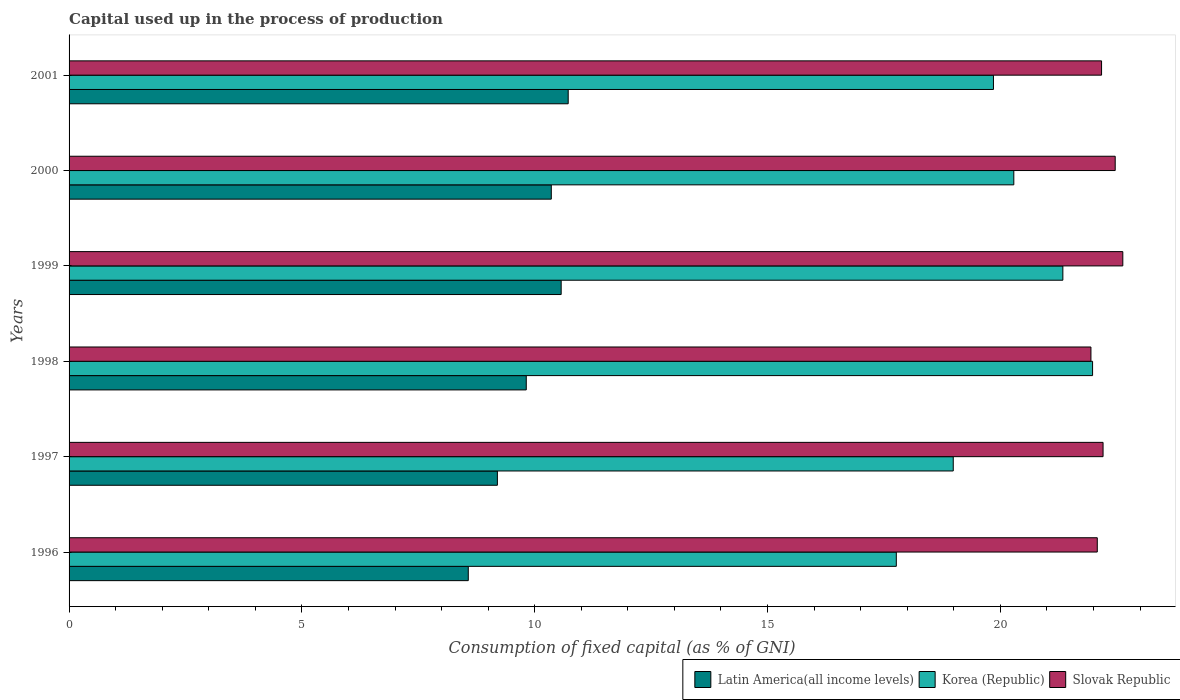How many different coloured bars are there?
Offer a very short reply. 3. What is the capital used up in the process of production in Slovak Republic in 2000?
Give a very brief answer. 22.47. Across all years, what is the maximum capital used up in the process of production in Korea (Republic)?
Ensure brevity in your answer.  21.98. Across all years, what is the minimum capital used up in the process of production in Korea (Republic)?
Provide a succinct answer. 17.77. In which year was the capital used up in the process of production in Latin America(all income levels) minimum?
Make the answer very short. 1996. What is the total capital used up in the process of production in Korea (Republic) in the graph?
Your response must be concise. 120.22. What is the difference between the capital used up in the process of production in Latin America(all income levels) in 1996 and that in 2000?
Your answer should be compact. -1.78. What is the difference between the capital used up in the process of production in Latin America(all income levels) in 1996 and the capital used up in the process of production in Slovak Republic in 1997?
Your answer should be very brief. -13.63. What is the average capital used up in the process of production in Slovak Republic per year?
Make the answer very short. 22.25. In the year 2000, what is the difference between the capital used up in the process of production in Korea (Republic) and capital used up in the process of production in Latin America(all income levels)?
Provide a short and direct response. 9.93. What is the ratio of the capital used up in the process of production in Slovak Republic in 1998 to that in 2000?
Make the answer very short. 0.98. Is the capital used up in the process of production in Latin America(all income levels) in 1997 less than that in 2000?
Your answer should be compact. Yes. What is the difference between the highest and the second highest capital used up in the process of production in Korea (Republic)?
Keep it short and to the point. 0.64. What is the difference between the highest and the lowest capital used up in the process of production in Slovak Republic?
Provide a short and direct response. 0.68. In how many years, is the capital used up in the process of production in Slovak Republic greater than the average capital used up in the process of production in Slovak Republic taken over all years?
Ensure brevity in your answer.  2. What does the 1st bar from the top in 1997 represents?
Provide a short and direct response. Slovak Republic. How many bars are there?
Make the answer very short. 18. Are all the bars in the graph horizontal?
Offer a terse response. Yes. How many years are there in the graph?
Offer a terse response. 6. Are the values on the major ticks of X-axis written in scientific E-notation?
Offer a terse response. No. Does the graph contain grids?
Keep it short and to the point. No. Where does the legend appear in the graph?
Make the answer very short. Bottom right. How many legend labels are there?
Keep it short and to the point. 3. What is the title of the graph?
Offer a terse response. Capital used up in the process of production. Does "Australia" appear as one of the legend labels in the graph?
Your answer should be compact. No. What is the label or title of the X-axis?
Offer a very short reply. Consumption of fixed capital (as % of GNI). What is the label or title of the Y-axis?
Ensure brevity in your answer.  Years. What is the Consumption of fixed capital (as % of GNI) of Latin America(all income levels) in 1996?
Your answer should be compact. 8.57. What is the Consumption of fixed capital (as % of GNI) in Korea (Republic) in 1996?
Provide a succinct answer. 17.77. What is the Consumption of fixed capital (as % of GNI) of Slovak Republic in 1996?
Make the answer very short. 22.08. What is the Consumption of fixed capital (as % of GNI) of Latin America(all income levels) in 1997?
Ensure brevity in your answer.  9.2. What is the Consumption of fixed capital (as % of GNI) of Korea (Republic) in 1997?
Make the answer very short. 18.99. What is the Consumption of fixed capital (as % of GNI) in Slovak Republic in 1997?
Your answer should be compact. 22.21. What is the Consumption of fixed capital (as % of GNI) in Latin America(all income levels) in 1998?
Your answer should be compact. 9.82. What is the Consumption of fixed capital (as % of GNI) in Korea (Republic) in 1998?
Offer a terse response. 21.98. What is the Consumption of fixed capital (as % of GNI) in Slovak Republic in 1998?
Provide a short and direct response. 21.95. What is the Consumption of fixed capital (as % of GNI) of Latin America(all income levels) in 1999?
Offer a very short reply. 10.57. What is the Consumption of fixed capital (as % of GNI) of Korea (Republic) in 1999?
Offer a terse response. 21.34. What is the Consumption of fixed capital (as % of GNI) of Slovak Republic in 1999?
Offer a very short reply. 22.63. What is the Consumption of fixed capital (as % of GNI) in Latin America(all income levels) in 2000?
Your response must be concise. 10.36. What is the Consumption of fixed capital (as % of GNI) of Korea (Republic) in 2000?
Give a very brief answer. 20.29. What is the Consumption of fixed capital (as % of GNI) of Slovak Republic in 2000?
Ensure brevity in your answer.  22.47. What is the Consumption of fixed capital (as % of GNI) of Latin America(all income levels) in 2001?
Your response must be concise. 10.72. What is the Consumption of fixed capital (as % of GNI) of Korea (Republic) in 2001?
Your answer should be very brief. 19.85. What is the Consumption of fixed capital (as % of GNI) in Slovak Republic in 2001?
Ensure brevity in your answer.  22.17. Across all years, what is the maximum Consumption of fixed capital (as % of GNI) of Latin America(all income levels)?
Provide a succinct answer. 10.72. Across all years, what is the maximum Consumption of fixed capital (as % of GNI) of Korea (Republic)?
Give a very brief answer. 21.98. Across all years, what is the maximum Consumption of fixed capital (as % of GNI) of Slovak Republic?
Offer a very short reply. 22.63. Across all years, what is the minimum Consumption of fixed capital (as % of GNI) in Latin America(all income levels)?
Give a very brief answer. 8.57. Across all years, what is the minimum Consumption of fixed capital (as % of GNI) in Korea (Republic)?
Provide a short and direct response. 17.77. Across all years, what is the minimum Consumption of fixed capital (as % of GNI) of Slovak Republic?
Give a very brief answer. 21.95. What is the total Consumption of fixed capital (as % of GNI) in Latin America(all income levels) in the graph?
Give a very brief answer. 59.23. What is the total Consumption of fixed capital (as % of GNI) in Korea (Republic) in the graph?
Provide a short and direct response. 120.22. What is the total Consumption of fixed capital (as % of GNI) in Slovak Republic in the graph?
Provide a succinct answer. 133.5. What is the difference between the Consumption of fixed capital (as % of GNI) of Latin America(all income levels) in 1996 and that in 1997?
Provide a succinct answer. -0.63. What is the difference between the Consumption of fixed capital (as % of GNI) in Korea (Republic) in 1996 and that in 1997?
Offer a terse response. -1.22. What is the difference between the Consumption of fixed capital (as % of GNI) of Slovak Republic in 1996 and that in 1997?
Keep it short and to the point. -0.12. What is the difference between the Consumption of fixed capital (as % of GNI) in Latin America(all income levels) in 1996 and that in 1998?
Ensure brevity in your answer.  -1.25. What is the difference between the Consumption of fixed capital (as % of GNI) of Korea (Republic) in 1996 and that in 1998?
Make the answer very short. -4.21. What is the difference between the Consumption of fixed capital (as % of GNI) in Slovak Republic in 1996 and that in 1998?
Make the answer very short. 0.14. What is the difference between the Consumption of fixed capital (as % of GNI) in Latin America(all income levels) in 1996 and that in 1999?
Keep it short and to the point. -1.99. What is the difference between the Consumption of fixed capital (as % of GNI) of Korea (Republic) in 1996 and that in 1999?
Provide a short and direct response. -3.58. What is the difference between the Consumption of fixed capital (as % of GNI) in Slovak Republic in 1996 and that in 1999?
Your response must be concise. -0.55. What is the difference between the Consumption of fixed capital (as % of GNI) in Latin America(all income levels) in 1996 and that in 2000?
Your answer should be compact. -1.78. What is the difference between the Consumption of fixed capital (as % of GNI) in Korea (Republic) in 1996 and that in 2000?
Provide a succinct answer. -2.52. What is the difference between the Consumption of fixed capital (as % of GNI) in Slovak Republic in 1996 and that in 2000?
Offer a terse response. -0.38. What is the difference between the Consumption of fixed capital (as % of GNI) in Latin America(all income levels) in 1996 and that in 2001?
Your answer should be compact. -2.15. What is the difference between the Consumption of fixed capital (as % of GNI) of Korea (Republic) in 1996 and that in 2001?
Offer a terse response. -2.09. What is the difference between the Consumption of fixed capital (as % of GNI) of Slovak Republic in 1996 and that in 2001?
Offer a terse response. -0.09. What is the difference between the Consumption of fixed capital (as % of GNI) of Latin America(all income levels) in 1997 and that in 1998?
Make the answer very short. -0.62. What is the difference between the Consumption of fixed capital (as % of GNI) of Korea (Republic) in 1997 and that in 1998?
Offer a very short reply. -2.99. What is the difference between the Consumption of fixed capital (as % of GNI) in Slovak Republic in 1997 and that in 1998?
Ensure brevity in your answer.  0.26. What is the difference between the Consumption of fixed capital (as % of GNI) of Latin America(all income levels) in 1997 and that in 1999?
Provide a succinct answer. -1.37. What is the difference between the Consumption of fixed capital (as % of GNI) of Korea (Republic) in 1997 and that in 1999?
Provide a short and direct response. -2.35. What is the difference between the Consumption of fixed capital (as % of GNI) in Slovak Republic in 1997 and that in 1999?
Keep it short and to the point. -0.42. What is the difference between the Consumption of fixed capital (as % of GNI) in Latin America(all income levels) in 1997 and that in 2000?
Provide a short and direct response. -1.16. What is the difference between the Consumption of fixed capital (as % of GNI) of Korea (Republic) in 1997 and that in 2000?
Your answer should be compact. -1.3. What is the difference between the Consumption of fixed capital (as % of GNI) of Slovak Republic in 1997 and that in 2000?
Your answer should be very brief. -0.26. What is the difference between the Consumption of fixed capital (as % of GNI) in Latin America(all income levels) in 1997 and that in 2001?
Ensure brevity in your answer.  -1.52. What is the difference between the Consumption of fixed capital (as % of GNI) in Korea (Republic) in 1997 and that in 2001?
Give a very brief answer. -0.86. What is the difference between the Consumption of fixed capital (as % of GNI) in Slovak Republic in 1997 and that in 2001?
Ensure brevity in your answer.  0.03. What is the difference between the Consumption of fixed capital (as % of GNI) of Latin America(all income levels) in 1998 and that in 1999?
Your answer should be compact. -0.75. What is the difference between the Consumption of fixed capital (as % of GNI) in Korea (Republic) in 1998 and that in 1999?
Offer a terse response. 0.64. What is the difference between the Consumption of fixed capital (as % of GNI) in Slovak Republic in 1998 and that in 1999?
Give a very brief answer. -0.68. What is the difference between the Consumption of fixed capital (as % of GNI) of Latin America(all income levels) in 1998 and that in 2000?
Provide a short and direct response. -0.54. What is the difference between the Consumption of fixed capital (as % of GNI) in Korea (Republic) in 1998 and that in 2000?
Keep it short and to the point. 1.69. What is the difference between the Consumption of fixed capital (as % of GNI) in Slovak Republic in 1998 and that in 2000?
Provide a short and direct response. -0.52. What is the difference between the Consumption of fixed capital (as % of GNI) of Latin America(all income levels) in 1998 and that in 2001?
Your answer should be very brief. -0.9. What is the difference between the Consumption of fixed capital (as % of GNI) in Korea (Republic) in 1998 and that in 2001?
Ensure brevity in your answer.  2.13. What is the difference between the Consumption of fixed capital (as % of GNI) of Slovak Republic in 1998 and that in 2001?
Provide a succinct answer. -0.23. What is the difference between the Consumption of fixed capital (as % of GNI) in Latin America(all income levels) in 1999 and that in 2000?
Your answer should be very brief. 0.21. What is the difference between the Consumption of fixed capital (as % of GNI) in Korea (Republic) in 1999 and that in 2000?
Ensure brevity in your answer.  1.05. What is the difference between the Consumption of fixed capital (as % of GNI) in Slovak Republic in 1999 and that in 2000?
Your response must be concise. 0.16. What is the difference between the Consumption of fixed capital (as % of GNI) in Latin America(all income levels) in 1999 and that in 2001?
Make the answer very short. -0.15. What is the difference between the Consumption of fixed capital (as % of GNI) in Korea (Republic) in 1999 and that in 2001?
Your response must be concise. 1.49. What is the difference between the Consumption of fixed capital (as % of GNI) in Slovak Republic in 1999 and that in 2001?
Ensure brevity in your answer.  0.46. What is the difference between the Consumption of fixed capital (as % of GNI) of Latin America(all income levels) in 2000 and that in 2001?
Your answer should be compact. -0.36. What is the difference between the Consumption of fixed capital (as % of GNI) of Korea (Republic) in 2000 and that in 2001?
Your answer should be very brief. 0.44. What is the difference between the Consumption of fixed capital (as % of GNI) in Slovak Republic in 2000 and that in 2001?
Your answer should be very brief. 0.29. What is the difference between the Consumption of fixed capital (as % of GNI) of Latin America(all income levels) in 1996 and the Consumption of fixed capital (as % of GNI) of Korea (Republic) in 1997?
Ensure brevity in your answer.  -10.41. What is the difference between the Consumption of fixed capital (as % of GNI) of Latin America(all income levels) in 1996 and the Consumption of fixed capital (as % of GNI) of Slovak Republic in 1997?
Provide a succinct answer. -13.63. What is the difference between the Consumption of fixed capital (as % of GNI) in Korea (Republic) in 1996 and the Consumption of fixed capital (as % of GNI) in Slovak Republic in 1997?
Provide a short and direct response. -4.44. What is the difference between the Consumption of fixed capital (as % of GNI) in Latin America(all income levels) in 1996 and the Consumption of fixed capital (as % of GNI) in Korea (Republic) in 1998?
Give a very brief answer. -13.41. What is the difference between the Consumption of fixed capital (as % of GNI) in Latin America(all income levels) in 1996 and the Consumption of fixed capital (as % of GNI) in Slovak Republic in 1998?
Offer a very short reply. -13.37. What is the difference between the Consumption of fixed capital (as % of GNI) of Korea (Republic) in 1996 and the Consumption of fixed capital (as % of GNI) of Slovak Republic in 1998?
Offer a very short reply. -4.18. What is the difference between the Consumption of fixed capital (as % of GNI) of Latin America(all income levels) in 1996 and the Consumption of fixed capital (as % of GNI) of Korea (Republic) in 1999?
Make the answer very short. -12.77. What is the difference between the Consumption of fixed capital (as % of GNI) in Latin America(all income levels) in 1996 and the Consumption of fixed capital (as % of GNI) in Slovak Republic in 1999?
Provide a short and direct response. -14.06. What is the difference between the Consumption of fixed capital (as % of GNI) in Korea (Republic) in 1996 and the Consumption of fixed capital (as % of GNI) in Slovak Republic in 1999?
Your answer should be compact. -4.86. What is the difference between the Consumption of fixed capital (as % of GNI) of Latin America(all income levels) in 1996 and the Consumption of fixed capital (as % of GNI) of Korea (Republic) in 2000?
Offer a terse response. -11.72. What is the difference between the Consumption of fixed capital (as % of GNI) in Latin America(all income levels) in 1996 and the Consumption of fixed capital (as % of GNI) in Slovak Republic in 2000?
Your answer should be compact. -13.89. What is the difference between the Consumption of fixed capital (as % of GNI) of Korea (Republic) in 1996 and the Consumption of fixed capital (as % of GNI) of Slovak Republic in 2000?
Your response must be concise. -4.7. What is the difference between the Consumption of fixed capital (as % of GNI) of Latin America(all income levels) in 1996 and the Consumption of fixed capital (as % of GNI) of Korea (Republic) in 2001?
Provide a short and direct response. -11.28. What is the difference between the Consumption of fixed capital (as % of GNI) of Latin America(all income levels) in 1996 and the Consumption of fixed capital (as % of GNI) of Slovak Republic in 2001?
Your response must be concise. -13.6. What is the difference between the Consumption of fixed capital (as % of GNI) in Korea (Republic) in 1996 and the Consumption of fixed capital (as % of GNI) in Slovak Republic in 2001?
Your response must be concise. -4.41. What is the difference between the Consumption of fixed capital (as % of GNI) of Latin America(all income levels) in 1997 and the Consumption of fixed capital (as % of GNI) of Korea (Republic) in 1998?
Offer a very short reply. -12.78. What is the difference between the Consumption of fixed capital (as % of GNI) in Latin America(all income levels) in 1997 and the Consumption of fixed capital (as % of GNI) in Slovak Republic in 1998?
Offer a terse response. -12.75. What is the difference between the Consumption of fixed capital (as % of GNI) of Korea (Republic) in 1997 and the Consumption of fixed capital (as % of GNI) of Slovak Republic in 1998?
Your answer should be very brief. -2.96. What is the difference between the Consumption of fixed capital (as % of GNI) in Latin America(all income levels) in 1997 and the Consumption of fixed capital (as % of GNI) in Korea (Republic) in 1999?
Your response must be concise. -12.14. What is the difference between the Consumption of fixed capital (as % of GNI) in Latin America(all income levels) in 1997 and the Consumption of fixed capital (as % of GNI) in Slovak Republic in 1999?
Give a very brief answer. -13.43. What is the difference between the Consumption of fixed capital (as % of GNI) of Korea (Republic) in 1997 and the Consumption of fixed capital (as % of GNI) of Slovak Republic in 1999?
Your response must be concise. -3.64. What is the difference between the Consumption of fixed capital (as % of GNI) of Latin America(all income levels) in 1997 and the Consumption of fixed capital (as % of GNI) of Korea (Republic) in 2000?
Give a very brief answer. -11.09. What is the difference between the Consumption of fixed capital (as % of GNI) in Latin America(all income levels) in 1997 and the Consumption of fixed capital (as % of GNI) in Slovak Republic in 2000?
Give a very brief answer. -13.27. What is the difference between the Consumption of fixed capital (as % of GNI) of Korea (Republic) in 1997 and the Consumption of fixed capital (as % of GNI) of Slovak Republic in 2000?
Your response must be concise. -3.48. What is the difference between the Consumption of fixed capital (as % of GNI) in Latin America(all income levels) in 1997 and the Consumption of fixed capital (as % of GNI) in Korea (Republic) in 2001?
Keep it short and to the point. -10.65. What is the difference between the Consumption of fixed capital (as % of GNI) in Latin America(all income levels) in 1997 and the Consumption of fixed capital (as % of GNI) in Slovak Republic in 2001?
Ensure brevity in your answer.  -12.97. What is the difference between the Consumption of fixed capital (as % of GNI) in Korea (Republic) in 1997 and the Consumption of fixed capital (as % of GNI) in Slovak Republic in 2001?
Make the answer very short. -3.19. What is the difference between the Consumption of fixed capital (as % of GNI) in Latin America(all income levels) in 1998 and the Consumption of fixed capital (as % of GNI) in Korea (Republic) in 1999?
Provide a succinct answer. -11.52. What is the difference between the Consumption of fixed capital (as % of GNI) of Latin America(all income levels) in 1998 and the Consumption of fixed capital (as % of GNI) of Slovak Republic in 1999?
Keep it short and to the point. -12.81. What is the difference between the Consumption of fixed capital (as % of GNI) in Korea (Republic) in 1998 and the Consumption of fixed capital (as % of GNI) in Slovak Republic in 1999?
Your answer should be compact. -0.65. What is the difference between the Consumption of fixed capital (as % of GNI) in Latin America(all income levels) in 1998 and the Consumption of fixed capital (as % of GNI) in Korea (Republic) in 2000?
Your answer should be very brief. -10.47. What is the difference between the Consumption of fixed capital (as % of GNI) of Latin America(all income levels) in 1998 and the Consumption of fixed capital (as % of GNI) of Slovak Republic in 2000?
Your answer should be very brief. -12.65. What is the difference between the Consumption of fixed capital (as % of GNI) in Korea (Republic) in 1998 and the Consumption of fixed capital (as % of GNI) in Slovak Republic in 2000?
Keep it short and to the point. -0.49. What is the difference between the Consumption of fixed capital (as % of GNI) in Latin America(all income levels) in 1998 and the Consumption of fixed capital (as % of GNI) in Korea (Republic) in 2001?
Make the answer very short. -10.03. What is the difference between the Consumption of fixed capital (as % of GNI) of Latin America(all income levels) in 1998 and the Consumption of fixed capital (as % of GNI) of Slovak Republic in 2001?
Your answer should be compact. -12.35. What is the difference between the Consumption of fixed capital (as % of GNI) in Korea (Republic) in 1998 and the Consumption of fixed capital (as % of GNI) in Slovak Republic in 2001?
Ensure brevity in your answer.  -0.19. What is the difference between the Consumption of fixed capital (as % of GNI) of Latin America(all income levels) in 1999 and the Consumption of fixed capital (as % of GNI) of Korea (Republic) in 2000?
Offer a very short reply. -9.72. What is the difference between the Consumption of fixed capital (as % of GNI) in Latin America(all income levels) in 1999 and the Consumption of fixed capital (as % of GNI) in Slovak Republic in 2000?
Provide a short and direct response. -11.9. What is the difference between the Consumption of fixed capital (as % of GNI) of Korea (Republic) in 1999 and the Consumption of fixed capital (as % of GNI) of Slovak Republic in 2000?
Provide a short and direct response. -1.12. What is the difference between the Consumption of fixed capital (as % of GNI) of Latin America(all income levels) in 1999 and the Consumption of fixed capital (as % of GNI) of Korea (Republic) in 2001?
Keep it short and to the point. -9.28. What is the difference between the Consumption of fixed capital (as % of GNI) in Latin America(all income levels) in 1999 and the Consumption of fixed capital (as % of GNI) in Slovak Republic in 2001?
Ensure brevity in your answer.  -11.61. What is the difference between the Consumption of fixed capital (as % of GNI) of Korea (Republic) in 1999 and the Consumption of fixed capital (as % of GNI) of Slovak Republic in 2001?
Your answer should be compact. -0.83. What is the difference between the Consumption of fixed capital (as % of GNI) in Latin America(all income levels) in 2000 and the Consumption of fixed capital (as % of GNI) in Korea (Republic) in 2001?
Keep it short and to the point. -9.5. What is the difference between the Consumption of fixed capital (as % of GNI) in Latin America(all income levels) in 2000 and the Consumption of fixed capital (as % of GNI) in Slovak Republic in 2001?
Ensure brevity in your answer.  -11.82. What is the difference between the Consumption of fixed capital (as % of GNI) in Korea (Republic) in 2000 and the Consumption of fixed capital (as % of GNI) in Slovak Republic in 2001?
Offer a very short reply. -1.88. What is the average Consumption of fixed capital (as % of GNI) of Latin America(all income levels) per year?
Offer a terse response. 9.87. What is the average Consumption of fixed capital (as % of GNI) of Korea (Republic) per year?
Keep it short and to the point. 20.04. What is the average Consumption of fixed capital (as % of GNI) in Slovak Republic per year?
Offer a very short reply. 22.25. In the year 1996, what is the difference between the Consumption of fixed capital (as % of GNI) in Latin America(all income levels) and Consumption of fixed capital (as % of GNI) in Korea (Republic)?
Provide a short and direct response. -9.19. In the year 1996, what is the difference between the Consumption of fixed capital (as % of GNI) of Latin America(all income levels) and Consumption of fixed capital (as % of GNI) of Slovak Republic?
Your answer should be very brief. -13.51. In the year 1996, what is the difference between the Consumption of fixed capital (as % of GNI) of Korea (Republic) and Consumption of fixed capital (as % of GNI) of Slovak Republic?
Keep it short and to the point. -4.32. In the year 1997, what is the difference between the Consumption of fixed capital (as % of GNI) of Latin America(all income levels) and Consumption of fixed capital (as % of GNI) of Korea (Republic)?
Offer a terse response. -9.79. In the year 1997, what is the difference between the Consumption of fixed capital (as % of GNI) of Latin America(all income levels) and Consumption of fixed capital (as % of GNI) of Slovak Republic?
Keep it short and to the point. -13.01. In the year 1997, what is the difference between the Consumption of fixed capital (as % of GNI) of Korea (Republic) and Consumption of fixed capital (as % of GNI) of Slovak Republic?
Offer a terse response. -3.22. In the year 1998, what is the difference between the Consumption of fixed capital (as % of GNI) of Latin America(all income levels) and Consumption of fixed capital (as % of GNI) of Korea (Republic)?
Your answer should be very brief. -12.16. In the year 1998, what is the difference between the Consumption of fixed capital (as % of GNI) of Latin America(all income levels) and Consumption of fixed capital (as % of GNI) of Slovak Republic?
Make the answer very short. -12.13. In the year 1998, what is the difference between the Consumption of fixed capital (as % of GNI) in Korea (Republic) and Consumption of fixed capital (as % of GNI) in Slovak Republic?
Offer a terse response. 0.04. In the year 1999, what is the difference between the Consumption of fixed capital (as % of GNI) of Latin America(all income levels) and Consumption of fixed capital (as % of GNI) of Korea (Republic)?
Provide a succinct answer. -10.77. In the year 1999, what is the difference between the Consumption of fixed capital (as % of GNI) of Latin America(all income levels) and Consumption of fixed capital (as % of GNI) of Slovak Republic?
Offer a very short reply. -12.06. In the year 1999, what is the difference between the Consumption of fixed capital (as % of GNI) in Korea (Republic) and Consumption of fixed capital (as % of GNI) in Slovak Republic?
Offer a terse response. -1.29. In the year 2000, what is the difference between the Consumption of fixed capital (as % of GNI) in Latin America(all income levels) and Consumption of fixed capital (as % of GNI) in Korea (Republic)?
Provide a short and direct response. -9.93. In the year 2000, what is the difference between the Consumption of fixed capital (as % of GNI) of Latin America(all income levels) and Consumption of fixed capital (as % of GNI) of Slovak Republic?
Your answer should be very brief. -12.11. In the year 2000, what is the difference between the Consumption of fixed capital (as % of GNI) of Korea (Republic) and Consumption of fixed capital (as % of GNI) of Slovak Republic?
Your response must be concise. -2.18. In the year 2001, what is the difference between the Consumption of fixed capital (as % of GNI) in Latin America(all income levels) and Consumption of fixed capital (as % of GNI) in Korea (Republic)?
Your answer should be compact. -9.13. In the year 2001, what is the difference between the Consumption of fixed capital (as % of GNI) in Latin America(all income levels) and Consumption of fixed capital (as % of GNI) in Slovak Republic?
Make the answer very short. -11.45. In the year 2001, what is the difference between the Consumption of fixed capital (as % of GNI) in Korea (Republic) and Consumption of fixed capital (as % of GNI) in Slovak Republic?
Your answer should be compact. -2.32. What is the ratio of the Consumption of fixed capital (as % of GNI) in Latin America(all income levels) in 1996 to that in 1997?
Your answer should be compact. 0.93. What is the ratio of the Consumption of fixed capital (as % of GNI) of Korea (Republic) in 1996 to that in 1997?
Your answer should be very brief. 0.94. What is the ratio of the Consumption of fixed capital (as % of GNI) of Latin America(all income levels) in 1996 to that in 1998?
Ensure brevity in your answer.  0.87. What is the ratio of the Consumption of fixed capital (as % of GNI) in Korea (Republic) in 1996 to that in 1998?
Ensure brevity in your answer.  0.81. What is the ratio of the Consumption of fixed capital (as % of GNI) of Slovak Republic in 1996 to that in 1998?
Your answer should be compact. 1.01. What is the ratio of the Consumption of fixed capital (as % of GNI) of Latin America(all income levels) in 1996 to that in 1999?
Keep it short and to the point. 0.81. What is the ratio of the Consumption of fixed capital (as % of GNI) of Korea (Republic) in 1996 to that in 1999?
Provide a short and direct response. 0.83. What is the ratio of the Consumption of fixed capital (as % of GNI) in Slovak Republic in 1996 to that in 1999?
Ensure brevity in your answer.  0.98. What is the ratio of the Consumption of fixed capital (as % of GNI) in Latin America(all income levels) in 1996 to that in 2000?
Your answer should be very brief. 0.83. What is the ratio of the Consumption of fixed capital (as % of GNI) of Korea (Republic) in 1996 to that in 2000?
Keep it short and to the point. 0.88. What is the ratio of the Consumption of fixed capital (as % of GNI) of Slovak Republic in 1996 to that in 2000?
Your answer should be very brief. 0.98. What is the ratio of the Consumption of fixed capital (as % of GNI) in Latin America(all income levels) in 1996 to that in 2001?
Provide a short and direct response. 0.8. What is the ratio of the Consumption of fixed capital (as % of GNI) of Korea (Republic) in 1996 to that in 2001?
Keep it short and to the point. 0.89. What is the ratio of the Consumption of fixed capital (as % of GNI) in Slovak Republic in 1996 to that in 2001?
Give a very brief answer. 1. What is the ratio of the Consumption of fixed capital (as % of GNI) in Latin America(all income levels) in 1997 to that in 1998?
Your answer should be compact. 0.94. What is the ratio of the Consumption of fixed capital (as % of GNI) in Korea (Republic) in 1997 to that in 1998?
Keep it short and to the point. 0.86. What is the ratio of the Consumption of fixed capital (as % of GNI) in Slovak Republic in 1997 to that in 1998?
Your answer should be very brief. 1.01. What is the ratio of the Consumption of fixed capital (as % of GNI) of Latin America(all income levels) in 1997 to that in 1999?
Provide a short and direct response. 0.87. What is the ratio of the Consumption of fixed capital (as % of GNI) in Korea (Republic) in 1997 to that in 1999?
Your answer should be very brief. 0.89. What is the ratio of the Consumption of fixed capital (as % of GNI) in Slovak Republic in 1997 to that in 1999?
Your answer should be very brief. 0.98. What is the ratio of the Consumption of fixed capital (as % of GNI) of Latin America(all income levels) in 1997 to that in 2000?
Your answer should be compact. 0.89. What is the ratio of the Consumption of fixed capital (as % of GNI) in Korea (Republic) in 1997 to that in 2000?
Offer a terse response. 0.94. What is the ratio of the Consumption of fixed capital (as % of GNI) of Slovak Republic in 1997 to that in 2000?
Provide a succinct answer. 0.99. What is the ratio of the Consumption of fixed capital (as % of GNI) in Latin America(all income levels) in 1997 to that in 2001?
Your response must be concise. 0.86. What is the ratio of the Consumption of fixed capital (as % of GNI) in Korea (Republic) in 1997 to that in 2001?
Give a very brief answer. 0.96. What is the ratio of the Consumption of fixed capital (as % of GNI) of Latin America(all income levels) in 1998 to that in 1999?
Give a very brief answer. 0.93. What is the ratio of the Consumption of fixed capital (as % of GNI) of Korea (Republic) in 1998 to that in 1999?
Ensure brevity in your answer.  1.03. What is the ratio of the Consumption of fixed capital (as % of GNI) of Slovak Republic in 1998 to that in 1999?
Your answer should be very brief. 0.97. What is the ratio of the Consumption of fixed capital (as % of GNI) in Latin America(all income levels) in 1998 to that in 2000?
Provide a short and direct response. 0.95. What is the ratio of the Consumption of fixed capital (as % of GNI) of Korea (Republic) in 1998 to that in 2000?
Your answer should be very brief. 1.08. What is the ratio of the Consumption of fixed capital (as % of GNI) of Slovak Republic in 1998 to that in 2000?
Give a very brief answer. 0.98. What is the ratio of the Consumption of fixed capital (as % of GNI) in Latin America(all income levels) in 1998 to that in 2001?
Offer a terse response. 0.92. What is the ratio of the Consumption of fixed capital (as % of GNI) of Korea (Republic) in 1998 to that in 2001?
Your answer should be very brief. 1.11. What is the ratio of the Consumption of fixed capital (as % of GNI) in Slovak Republic in 1998 to that in 2001?
Keep it short and to the point. 0.99. What is the ratio of the Consumption of fixed capital (as % of GNI) in Latin America(all income levels) in 1999 to that in 2000?
Provide a short and direct response. 1.02. What is the ratio of the Consumption of fixed capital (as % of GNI) in Korea (Republic) in 1999 to that in 2000?
Ensure brevity in your answer.  1.05. What is the ratio of the Consumption of fixed capital (as % of GNI) of Slovak Republic in 1999 to that in 2000?
Offer a terse response. 1.01. What is the ratio of the Consumption of fixed capital (as % of GNI) of Latin America(all income levels) in 1999 to that in 2001?
Ensure brevity in your answer.  0.99. What is the ratio of the Consumption of fixed capital (as % of GNI) of Korea (Republic) in 1999 to that in 2001?
Offer a terse response. 1.08. What is the ratio of the Consumption of fixed capital (as % of GNI) in Slovak Republic in 1999 to that in 2001?
Offer a terse response. 1.02. What is the ratio of the Consumption of fixed capital (as % of GNI) of Latin America(all income levels) in 2000 to that in 2001?
Your answer should be compact. 0.97. What is the ratio of the Consumption of fixed capital (as % of GNI) in Slovak Republic in 2000 to that in 2001?
Ensure brevity in your answer.  1.01. What is the difference between the highest and the second highest Consumption of fixed capital (as % of GNI) in Latin America(all income levels)?
Offer a terse response. 0.15. What is the difference between the highest and the second highest Consumption of fixed capital (as % of GNI) in Korea (Republic)?
Your answer should be very brief. 0.64. What is the difference between the highest and the second highest Consumption of fixed capital (as % of GNI) in Slovak Republic?
Keep it short and to the point. 0.16. What is the difference between the highest and the lowest Consumption of fixed capital (as % of GNI) of Latin America(all income levels)?
Provide a succinct answer. 2.15. What is the difference between the highest and the lowest Consumption of fixed capital (as % of GNI) in Korea (Republic)?
Make the answer very short. 4.21. What is the difference between the highest and the lowest Consumption of fixed capital (as % of GNI) in Slovak Republic?
Your response must be concise. 0.68. 